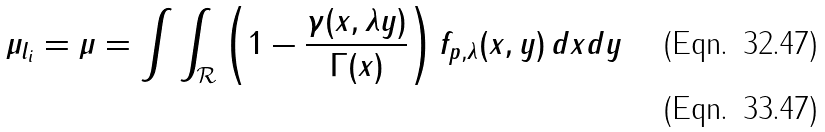Convert formula to latex. <formula><loc_0><loc_0><loc_500><loc_500>\mu _ { l _ { i } } = \mu = \int \int _ { \mathcal { R } } \left ( 1 - \frac { \gamma ( x , \lambda y ) } { \Gamma ( x ) } \right ) f _ { p , \lambda } ( x , y ) \, d x d y \\</formula> 